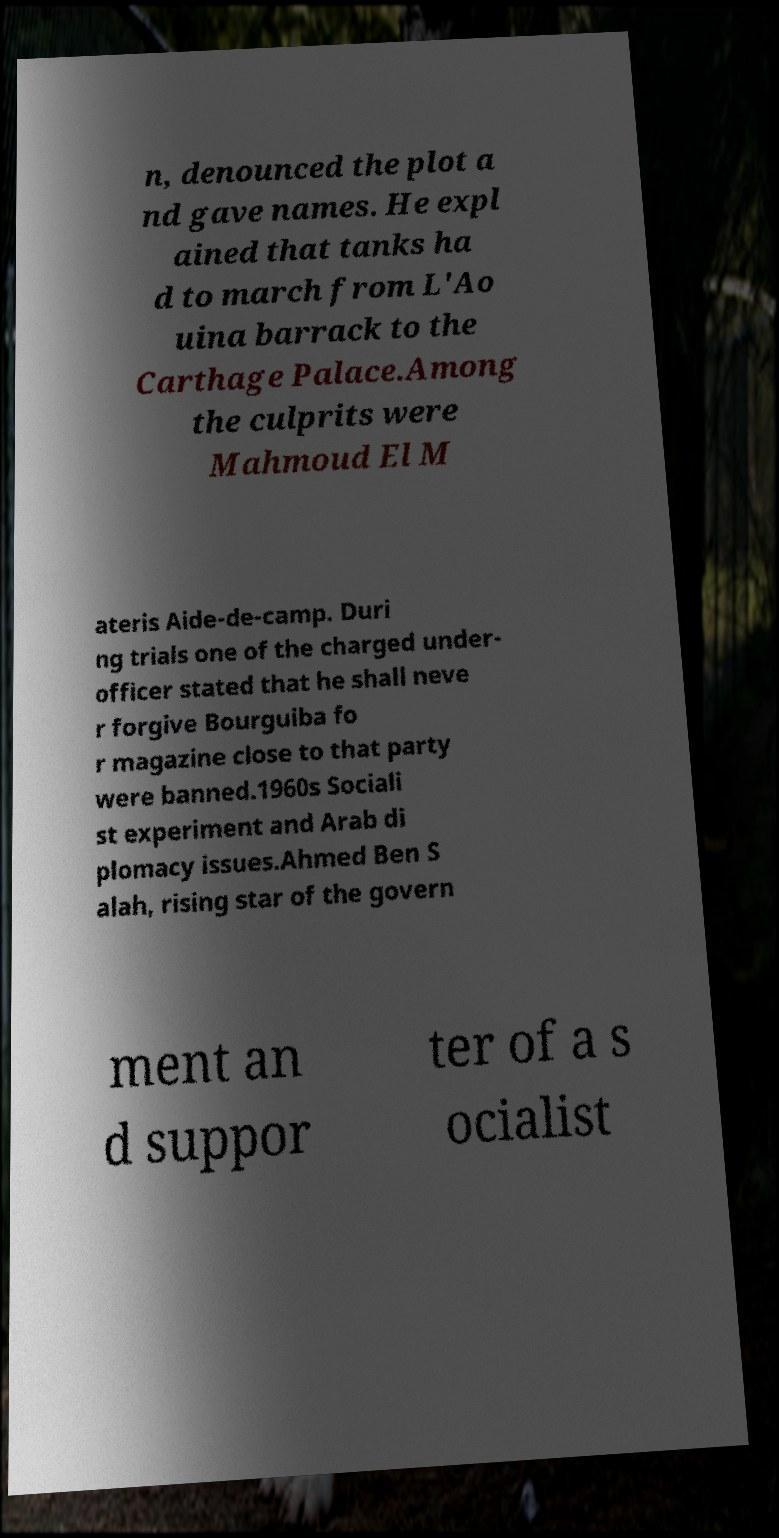Could you extract and type out the text from this image? n, denounced the plot a nd gave names. He expl ained that tanks ha d to march from L'Ao uina barrack to the Carthage Palace.Among the culprits were Mahmoud El M ateris Aide-de-camp. Duri ng trials one of the charged under- officer stated that he shall neve r forgive Bourguiba fo r magazine close to that party were banned.1960s Sociali st experiment and Arab di plomacy issues.Ahmed Ben S alah, rising star of the govern ment an d suppor ter of a s ocialist 